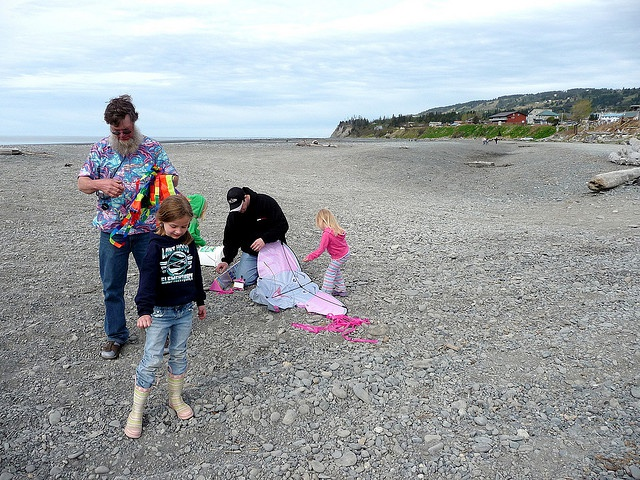Describe the objects in this image and their specific colors. I can see people in white, black, gray, darkgray, and navy tones, people in white, black, darkgray, and gray tones, people in white, black, gray, and darkgray tones, kite in white, lavender, darkgray, and violet tones, and people in white, violet, lightpink, darkgray, and brown tones in this image. 